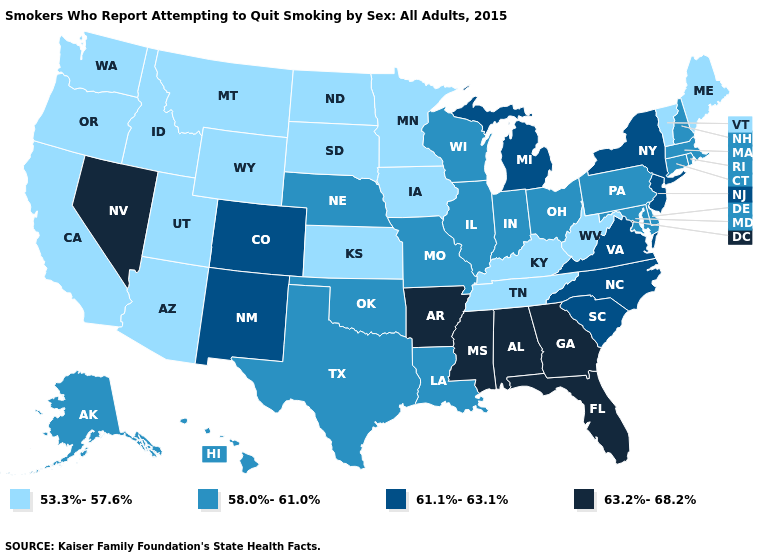Among the states that border Michigan , which have the highest value?
Keep it brief. Indiana, Ohio, Wisconsin. Does Oklahoma have a higher value than West Virginia?
Write a very short answer. Yes. What is the value of North Dakota?
Be succinct. 53.3%-57.6%. How many symbols are there in the legend?
Be succinct. 4. What is the lowest value in the USA?
Answer briefly. 53.3%-57.6%. Name the states that have a value in the range 63.2%-68.2%?
Answer briefly. Alabama, Arkansas, Florida, Georgia, Mississippi, Nevada. What is the lowest value in states that border Connecticut?
Keep it brief. 58.0%-61.0%. Name the states that have a value in the range 58.0%-61.0%?
Write a very short answer. Alaska, Connecticut, Delaware, Hawaii, Illinois, Indiana, Louisiana, Maryland, Massachusetts, Missouri, Nebraska, New Hampshire, Ohio, Oklahoma, Pennsylvania, Rhode Island, Texas, Wisconsin. Does Vermont have a lower value than Arkansas?
Write a very short answer. Yes. What is the highest value in the USA?
Answer briefly. 63.2%-68.2%. What is the highest value in the USA?
Give a very brief answer. 63.2%-68.2%. Does Vermont have the lowest value in the USA?
Answer briefly. Yes. Which states hav the highest value in the South?
Write a very short answer. Alabama, Arkansas, Florida, Georgia, Mississippi. What is the highest value in the MidWest ?
Quick response, please. 61.1%-63.1%. What is the value of New York?
Write a very short answer. 61.1%-63.1%. 